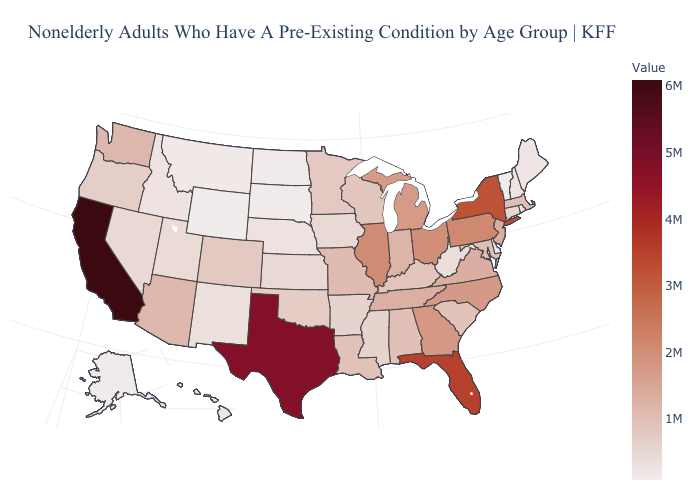Which states have the highest value in the USA?
Answer briefly. California. Does Texas have the highest value in the USA?
Short answer required. No. Among the states that border Minnesota , does Wisconsin have the highest value?
Keep it brief. Yes. Does New York have the highest value in the Northeast?
Give a very brief answer. Yes. Which states hav the highest value in the Northeast?
Be succinct. New York. Which states have the lowest value in the West?
Be succinct. Wyoming. 